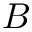Convert formula to latex. <formula><loc_0><loc_0><loc_500><loc_500>B</formula> 